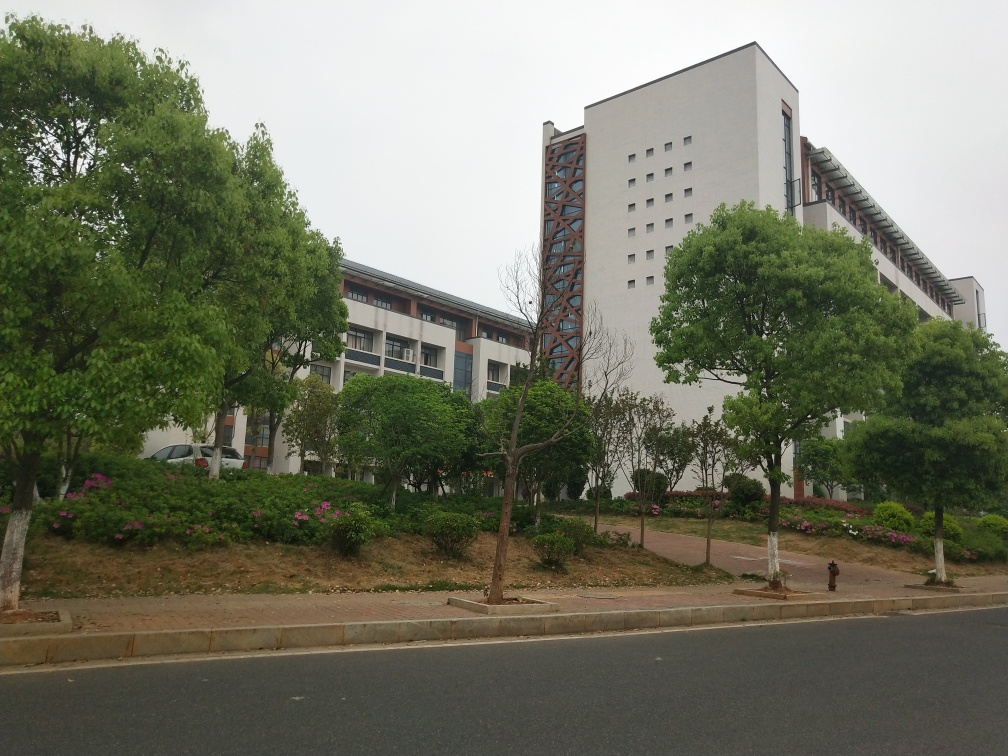What is the weather like in the image? The sky is overcast, indicating a cloudy day. The lighting suggests it could be either early morning or late afternoon, with no shadows visible that would indicate strong sunlight. The weather overall looks mild without any signs of rain. 